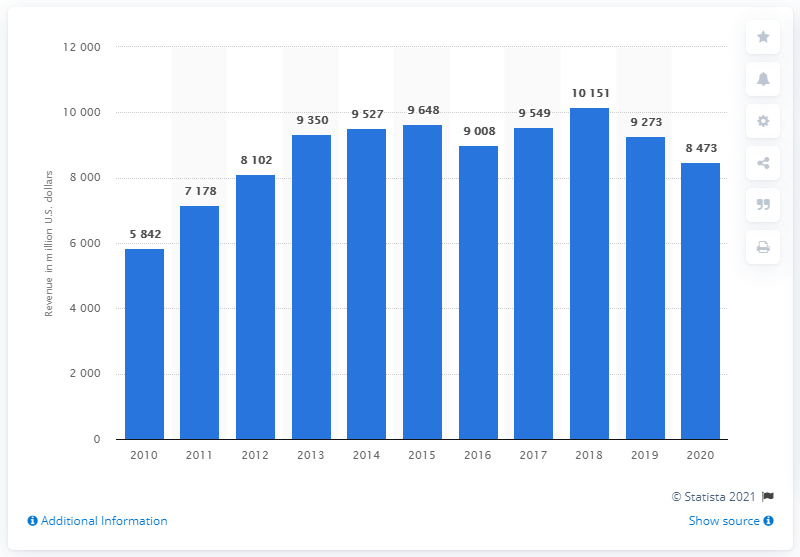Outline some significant characteristics in this image. The Eastman Chemical Company generated approximately $8,473 million in sales revenues in 2020. 